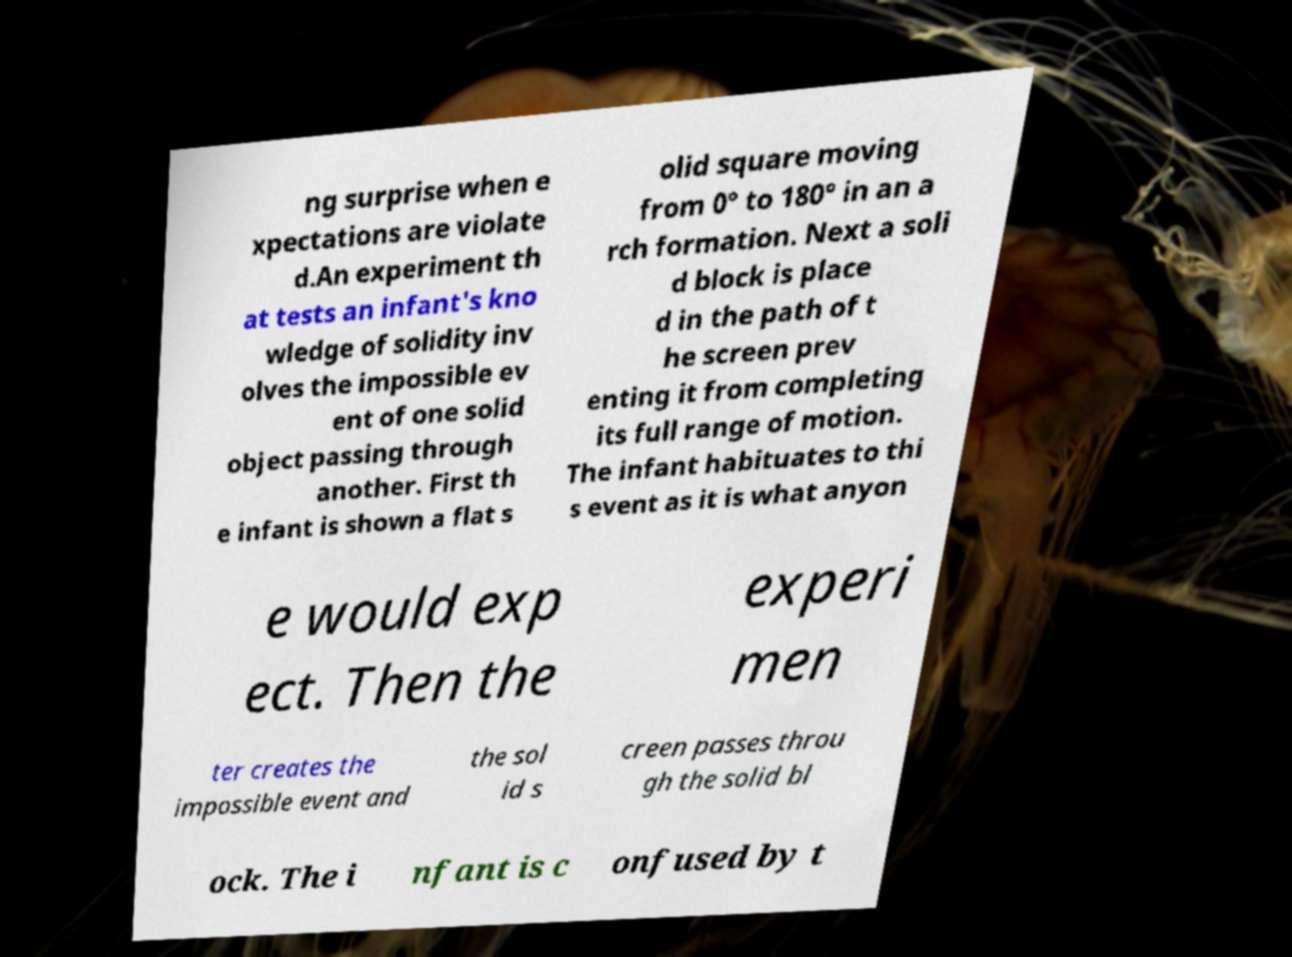I need the written content from this picture converted into text. Can you do that? ng surprise when e xpectations are violate d.An experiment th at tests an infant's kno wledge of solidity inv olves the impossible ev ent of one solid object passing through another. First th e infant is shown a flat s olid square moving from 0° to 180° in an a rch formation. Next a soli d block is place d in the path of t he screen prev enting it from completing its full range of motion. The infant habituates to thi s event as it is what anyon e would exp ect. Then the experi men ter creates the impossible event and the sol id s creen passes throu gh the solid bl ock. The i nfant is c onfused by t 